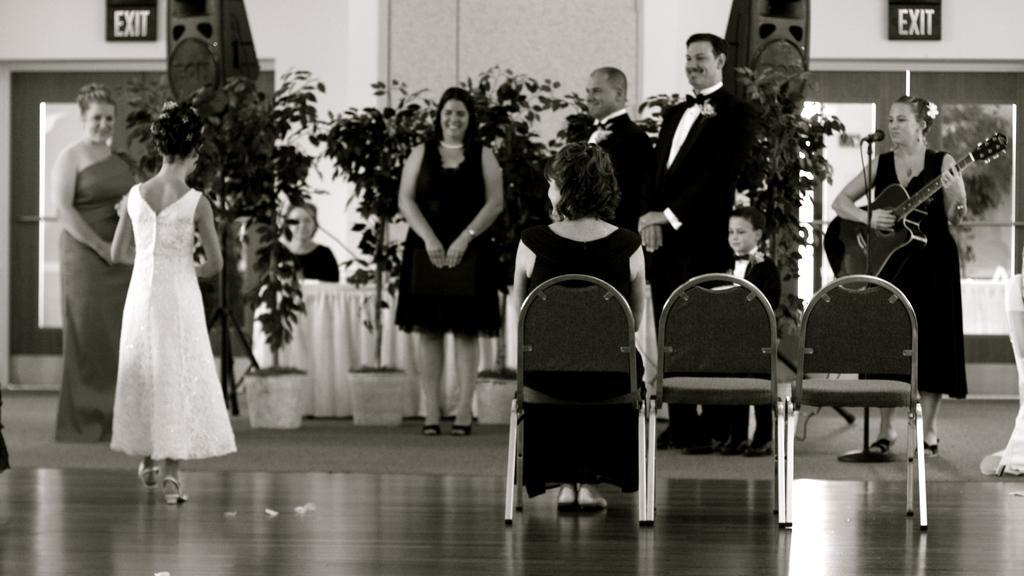Please provide a concise description of this image. In this image I can see people where one woman is sitting and rest everyone are standing. I can see a woman is holding a guitar, I can also see a mic in front of her. In the background I can see few plants and speakers. 